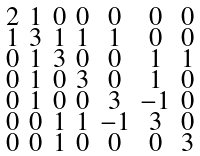<formula> <loc_0><loc_0><loc_500><loc_500>\begin{smallmatrix} 2 & 1 & 0 & 0 & 0 & 0 & 0 \\ 1 & 3 & 1 & 1 & 1 & 0 & 0 \\ 0 & 1 & 3 & 0 & 0 & 1 & 1 \\ 0 & 1 & 0 & 3 & 0 & 1 & 0 \\ 0 & 1 & 0 & 0 & 3 & - 1 & 0 \\ 0 & 0 & 1 & 1 & - 1 & 3 & 0 \\ 0 & 0 & 1 & 0 & 0 & 0 & 3 \end{smallmatrix}</formula> 